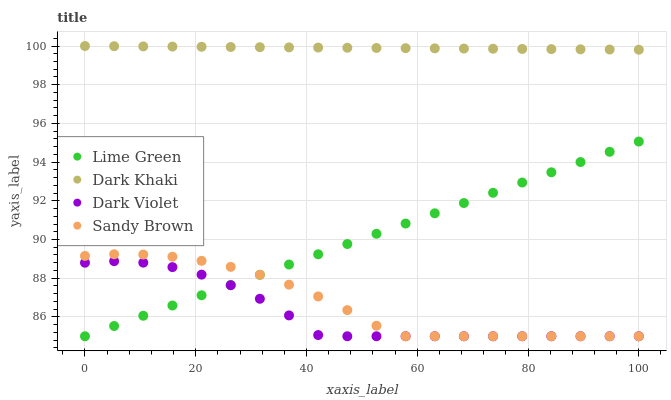Does Dark Violet have the minimum area under the curve?
Answer yes or no. Yes. Does Dark Khaki have the maximum area under the curve?
Answer yes or no. Yes. Does Sandy Brown have the minimum area under the curve?
Answer yes or no. No. Does Sandy Brown have the maximum area under the curve?
Answer yes or no. No. Is Lime Green the smoothest?
Answer yes or no. Yes. Is Dark Violet the roughest?
Answer yes or no. Yes. Is Sandy Brown the smoothest?
Answer yes or no. No. Is Sandy Brown the roughest?
Answer yes or no. No. Does Sandy Brown have the lowest value?
Answer yes or no. Yes. Does Dark Khaki have the highest value?
Answer yes or no. Yes. Does Sandy Brown have the highest value?
Answer yes or no. No. Is Lime Green less than Dark Khaki?
Answer yes or no. Yes. Is Dark Khaki greater than Dark Violet?
Answer yes or no. Yes. Does Lime Green intersect Dark Violet?
Answer yes or no. Yes. Is Lime Green less than Dark Violet?
Answer yes or no. No. Is Lime Green greater than Dark Violet?
Answer yes or no. No. Does Lime Green intersect Dark Khaki?
Answer yes or no. No. 